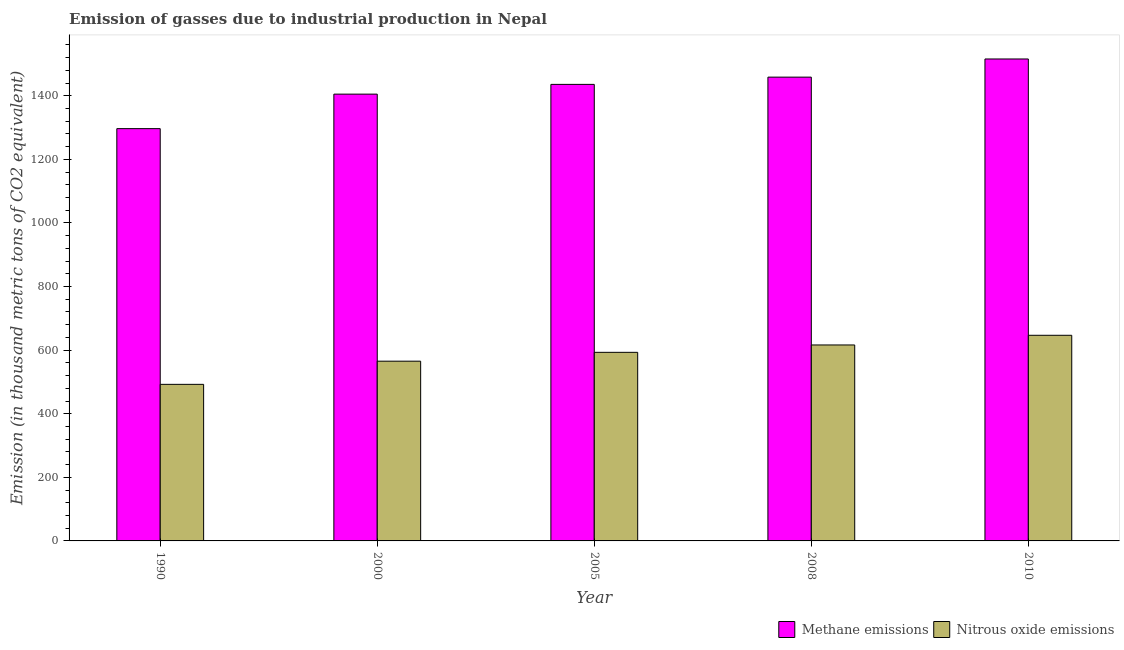Are the number of bars per tick equal to the number of legend labels?
Offer a very short reply. Yes. How many bars are there on the 3rd tick from the left?
Your response must be concise. 2. How many bars are there on the 2nd tick from the right?
Keep it short and to the point. 2. What is the label of the 1st group of bars from the left?
Your response must be concise. 1990. What is the amount of nitrous oxide emissions in 2005?
Provide a succinct answer. 593.1. Across all years, what is the maximum amount of methane emissions?
Offer a terse response. 1515.7. Across all years, what is the minimum amount of nitrous oxide emissions?
Give a very brief answer. 492.4. In which year was the amount of methane emissions minimum?
Your answer should be compact. 1990. What is the total amount of methane emissions in the graph?
Provide a short and direct response. 7111.8. What is the difference between the amount of nitrous oxide emissions in 2008 and that in 2010?
Your answer should be very brief. -30.4. What is the difference between the amount of nitrous oxide emissions in 2005 and the amount of methane emissions in 2010?
Keep it short and to the point. -53.6. What is the average amount of nitrous oxide emissions per year?
Provide a short and direct response. 582.76. In how many years, is the amount of nitrous oxide emissions greater than 640 thousand metric tons?
Offer a very short reply. 1. What is the ratio of the amount of methane emissions in 2005 to that in 2008?
Your answer should be compact. 0.98. What is the difference between the highest and the second highest amount of nitrous oxide emissions?
Your answer should be very brief. 30.4. What is the difference between the highest and the lowest amount of methane emissions?
Provide a succinct answer. 219.1. In how many years, is the amount of nitrous oxide emissions greater than the average amount of nitrous oxide emissions taken over all years?
Give a very brief answer. 3. What does the 2nd bar from the left in 2000 represents?
Offer a very short reply. Nitrous oxide emissions. What does the 1st bar from the right in 2010 represents?
Ensure brevity in your answer.  Nitrous oxide emissions. How many bars are there?
Give a very brief answer. 10. How many years are there in the graph?
Give a very brief answer. 5. Does the graph contain any zero values?
Ensure brevity in your answer.  No. How are the legend labels stacked?
Provide a short and direct response. Horizontal. What is the title of the graph?
Give a very brief answer. Emission of gasses due to industrial production in Nepal. What is the label or title of the Y-axis?
Ensure brevity in your answer.  Emission (in thousand metric tons of CO2 equivalent). What is the Emission (in thousand metric tons of CO2 equivalent) in Methane emissions in 1990?
Your response must be concise. 1296.6. What is the Emission (in thousand metric tons of CO2 equivalent) in Nitrous oxide emissions in 1990?
Give a very brief answer. 492.4. What is the Emission (in thousand metric tons of CO2 equivalent) of Methane emissions in 2000?
Offer a very short reply. 1405.1. What is the Emission (in thousand metric tons of CO2 equivalent) in Nitrous oxide emissions in 2000?
Keep it short and to the point. 565.3. What is the Emission (in thousand metric tons of CO2 equivalent) of Methane emissions in 2005?
Ensure brevity in your answer.  1435.8. What is the Emission (in thousand metric tons of CO2 equivalent) of Nitrous oxide emissions in 2005?
Offer a very short reply. 593.1. What is the Emission (in thousand metric tons of CO2 equivalent) of Methane emissions in 2008?
Offer a terse response. 1458.6. What is the Emission (in thousand metric tons of CO2 equivalent) of Nitrous oxide emissions in 2008?
Provide a succinct answer. 616.3. What is the Emission (in thousand metric tons of CO2 equivalent) of Methane emissions in 2010?
Your response must be concise. 1515.7. What is the Emission (in thousand metric tons of CO2 equivalent) of Nitrous oxide emissions in 2010?
Offer a terse response. 646.7. Across all years, what is the maximum Emission (in thousand metric tons of CO2 equivalent) of Methane emissions?
Keep it short and to the point. 1515.7. Across all years, what is the maximum Emission (in thousand metric tons of CO2 equivalent) in Nitrous oxide emissions?
Offer a terse response. 646.7. Across all years, what is the minimum Emission (in thousand metric tons of CO2 equivalent) in Methane emissions?
Give a very brief answer. 1296.6. Across all years, what is the minimum Emission (in thousand metric tons of CO2 equivalent) of Nitrous oxide emissions?
Give a very brief answer. 492.4. What is the total Emission (in thousand metric tons of CO2 equivalent) of Methane emissions in the graph?
Make the answer very short. 7111.8. What is the total Emission (in thousand metric tons of CO2 equivalent) in Nitrous oxide emissions in the graph?
Offer a very short reply. 2913.8. What is the difference between the Emission (in thousand metric tons of CO2 equivalent) of Methane emissions in 1990 and that in 2000?
Ensure brevity in your answer.  -108.5. What is the difference between the Emission (in thousand metric tons of CO2 equivalent) of Nitrous oxide emissions in 1990 and that in 2000?
Provide a succinct answer. -72.9. What is the difference between the Emission (in thousand metric tons of CO2 equivalent) of Methane emissions in 1990 and that in 2005?
Give a very brief answer. -139.2. What is the difference between the Emission (in thousand metric tons of CO2 equivalent) of Nitrous oxide emissions in 1990 and that in 2005?
Offer a terse response. -100.7. What is the difference between the Emission (in thousand metric tons of CO2 equivalent) of Methane emissions in 1990 and that in 2008?
Ensure brevity in your answer.  -162. What is the difference between the Emission (in thousand metric tons of CO2 equivalent) of Nitrous oxide emissions in 1990 and that in 2008?
Offer a very short reply. -123.9. What is the difference between the Emission (in thousand metric tons of CO2 equivalent) of Methane emissions in 1990 and that in 2010?
Make the answer very short. -219.1. What is the difference between the Emission (in thousand metric tons of CO2 equivalent) in Nitrous oxide emissions in 1990 and that in 2010?
Make the answer very short. -154.3. What is the difference between the Emission (in thousand metric tons of CO2 equivalent) in Methane emissions in 2000 and that in 2005?
Your answer should be very brief. -30.7. What is the difference between the Emission (in thousand metric tons of CO2 equivalent) in Nitrous oxide emissions in 2000 and that in 2005?
Offer a terse response. -27.8. What is the difference between the Emission (in thousand metric tons of CO2 equivalent) of Methane emissions in 2000 and that in 2008?
Offer a very short reply. -53.5. What is the difference between the Emission (in thousand metric tons of CO2 equivalent) in Nitrous oxide emissions in 2000 and that in 2008?
Make the answer very short. -51. What is the difference between the Emission (in thousand metric tons of CO2 equivalent) in Methane emissions in 2000 and that in 2010?
Provide a succinct answer. -110.6. What is the difference between the Emission (in thousand metric tons of CO2 equivalent) of Nitrous oxide emissions in 2000 and that in 2010?
Provide a short and direct response. -81.4. What is the difference between the Emission (in thousand metric tons of CO2 equivalent) of Methane emissions in 2005 and that in 2008?
Keep it short and to the point. -22.8. What is the difference between the Emission (in thousand metric tons of CO2 equivalent) of Nitrous oxide emissions in 2005 and that in 2008?
Keep it short and to the point. -23.2. What is the difference between the Emission (in thousand metric tons of CO2 equivalent) in Methane emissions in 2005 and that in 2010?
Ensure brevity in your answer.  -79.9. What is the difference between the Emission (in thousand metric tons of CO2 equivalent) of Nitrous oxide emissions in 2005 and that in 2010?
Provide a succinct answer. -53.6. What is the difference between the Emission (in thousand metric tons of CO2 equivalent) in Methane emissions in 2008 and that in 2010?
Ensure brevity in your answer.  -57.1. What is the difference between the Emission (in thousand metric tons of CO2 equivalent) of Nitrous oxide emissions in 2008 and that in 2010?
Your answer should be very brief. -30.4. What is the difference between the Emission (in thousand metric tons of CO2 equivalent) of Methane emissions in 1990 and the Emission (in thousand metric tons of CO2 equivalent) of Nitrous oxide emissions in 2000?
Ensure brevity in your answer.  731.3. What is the difference between the Emission (in thousand metric tons of CO2 equivalent) in Methane emissions in 1990 and the Emission (in thousand metric tons of CO2 equivalent) in Nitrous oxide emissions in 2005?
Your answer should be compact. 703.5. What is the difference between the Emission (in thousand metric tons of CO2 equivalent) of Methane emissions in 1990 and the Emission (in thousand metric tons of CO2 equivalent) of Nitrous oxide emissions in 2008?
Your answer should be compact. 680.3. What is the difference between the Emission (in thousand metric tons of CO2 equivalent) of Methane emissions in 1990 and the Emission (in thousand metric tons of CO2 equivalent) of Nitrous oxide emissions in 2010?
Your response must be concise. 649.9. What is the difference between the Emission (in thousand metric tons of CO2 equivalent) in Methane emissions in 2000 and the Emission (in thousand metric tons of CO2 equivalent) in Nitrous oxide emissions in 2005?
Provide a succinct answer. 812. What is the difference between the Emission (in thousand metric tons of CO2 equivalent) in Methane emissions in 2000 and the Emission (in thousand metric tons of CO2 equivalent) in Nitrous oxide emissions in 2008?
Make the answer very short. 788.8. What is the difference between the Emission (in thousand metric tons of CO2 equivalent) of Methane emissions in 2000 and the Emission (in thousand metric tons of CO2 equivalent) of Nitrous oxide emissions in 2010?
Offer a terse response. 758.4. What is the difference between the Emission (in thousand metric tons of CO2 equivalent) in Methane emissions in 2005 and the Emission (in thousand metric tons of CO2 equivalent) in Nitrous oxide emissions in 2008?
Offer a very short reply. 819.5. What is the difference between the Emission (in thousand metric tons of CO2 equivalent) in Methane emissions in 2005 and the Emission (in thousand metric tons of CO2 equivalent) in Nitrous oxide emissions in 2010?
Keep it short and to the point. 789.1. What is the difference between the Emission (in thousand metric tons of CO2 equivalent) in Methane emissions in 2008 and the Emission (in thousand metric tons of CO2 equivalent) in Nitrous oxide emissions in 2010?
Your answer should be compact. 811.9. What is the average Emission (in thousand metric tons of CO2 equivalent) of Methane emissions per year?
Your answer should be very brief. 1422.36. What is the average Emission (in thousand metric tons of CO2 equivalent) of Nitrous oxide emissions per year?
Provide a succinct answer. 582.76. In the year 1990, what is the difference between the Emission (in thousand metric tons of CO2 equivalent) of Methane emissions and Emission (in thousand metric tons of CO2 equivalent) of Nitrous oxide emissions?
Ensure brevity in your answer.  804.2. In the year 2000, what is the difference between the Emission (in thousand metric tons of CO2 equivalent) in Methane emissions and Emission (in thousand metric tons of CO2 equivalent) in Nitrous oxide emissions?
Make the answer very short. 839.8. In the year 2005, what is the difference between the Emission (in thousand metric tons of CO2 equivalent) in Methane emissions and Emission (in thousand metric tons of CO2 equivalent) in Nitrous oxide emissions?
Ensure brevity in your answer.  842.7. In the year 2008, what is the difference between the Emission (in thousand metric tons of CO2 equivalent) of Methane emissions and Emission (in thousand metric tons of CO2 equivalent) of Nitrous oxide emissions?
Offer a very short reply. 842.3. In the year 2010, what is the difference between the Emission (in thousand metric tons of CO2 equivalent) in Methane emissions and Emission (in thousand metric tons of CO2 equivalent) in Nitrous oxide emissions?
Make the answer very short. 869. What is the ratio of the Emission (in thousand metric tons of CO2 equivalent) in Methane emissions in 1990 to that in 2000?
Provide a short and direct response. 0.92. What is the ratio of the Emission (in thousand metric tons of CO2 equivalent) of Nitrous oxide emissions in 1990 to that in 2000?
Keep it short and to the point. 0.87. What is the ratio of the Emission (in thousand metric tons of CO2 equivalent) of Methane emissions in 1990 to that in 2005?
Your answer should be compact. 0.9. What is the ratio of the Emission (in thousand metric tons of CO2 equivalent) in Nitrous oxide emissions in 1990 to that in 2005?
Provide a short and direct response. 0.83. What is the ratio of the Emission (in thousand metric tons of CO2 equivalent) of Nitrous oxide emissions in 1990 to that in 2008?
Offer a very short reply. 0.8. What is the ratio of the Emission (in thousand metric tons of CO2 equivalent) in Methane emissions in 1990 to that in 2010?
Provide a succinct answer. 0.86. What is the ratio of the Emission (in thousand metric tons of CO2 equivalent) in Nitrous oxide emissions in 1990 to that in 2010?
Keep it short and to the point. 0.76. What is the ratio of the Emission (in thousand metric tons of CO2 equivalent) in Methane emissions in 2000 to that in 2005?
Offer a very short reply. 0.98. What is the ratio of the Emission (in thousand metric tons of CO2 equivalent) of Nitrous oxide emissions in 2000 to that in 2005?
Ensure brevity in your answer.  0.95. What is the ratio of the Emission (in thousand metric tons of CO2 equivalent) in Methane emissions in 2000 to that in 2008?
Keep it short and to the point. 0.96. What is the ratio of the Emission (in thousand metric tons of CO2 equivalent) of Nitrous oxide emissions in 2000 to that in 2008?
Your answer should be very brief. 0.92. What is the ratio of the Emission (in thousand metric tons of CO2 equivalent) of Methane emissions in 2000 to that in 2010?
Offer a terse response. 0.93. What is the ratio of the Emission (in thousand metric tons of CO2 equivalent) in Nitrous oxide emissions in 2000 to that in 2010?
Provide a short and direct response. 0.87. What is the ratio of the Emission (in thousand metric tons of CO2 equivalent) of Methane emissions in 2005 to that in 2008?
Give a very brief answer. 0.98. What is the ratio of the Emission (in thousand metric tons of CO2 equivalent) of Nitrous oxide emissions in 2005 to that in 2008?
Your answer should be very brief. 0.96. What is the ratio of the Emission (in thousand metric tons of CO2 equivalent) in Methane emissions in 2005 to that in 2010?
Provide a succinct answer. 0.95. What is the ratio of the Emission (in thousand metric tons of CO2 equivalent) of Nitrous oxide emissions in 2005 to that in 2010?
Provide a succinct answer. 0.92. What is the ratio of the Emission (in thousand metric tons of CO2 equivalent) of Methane emissions in 2008 to that in 2010?
Give a very brief answer. 0.96. What is the ratio of the Emission (in thousand metric tons of CO2 equivalent) in Nitrous oxide emissions in 2008 to that in 2010?
Provide a short and direct response. 0.95. What is the difference between the highest and the second highest Emission (in thousand metric tons of CO2 equivalent) in Methane emissions?
Provide a succinct answer. 57.1. What is the difference between the highest and the second highest Emission (in thousand metric tons of CO2 equivalent) of Nitrous oxide emissions?
Offer a terse response. 30.4. What is the difference between the highest and the lowest Emission (in thousand metric tons of CO2 equivalent) of Methane emissions?
Provide a succinct answer. 219.1. What is the difference between the highest and the lowest Emission (in thousand metric tons of CO2 equivalent) in Nitrous oxide emissions?
Your answer should be compact. 154.3. 